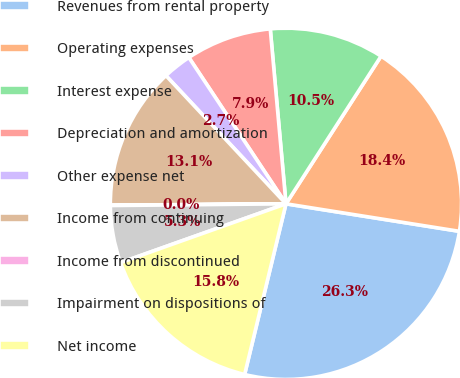Convert chart to OTSL. <chart><loc_0><loc_0><loc_500><loc_500><pie_chart><fcel>Revenues from rental property<fcel>Operating expenses<fcel>Interest expense<fcel>Depreciation and amortization<fcel>Other expense net<fcel>Income from continuing<fcel>Income from discontinued<fcel>Impairment on dispositions of<fcel>Net income<nl><fcel>26.28%<fcel>18.4%<fcel>10.53%<fcel>7.9%<fcel>2.65%<fcel>13.15%<fcel>0.03%<fcel>5.28%<fcel>15.78%<nl></chart> 